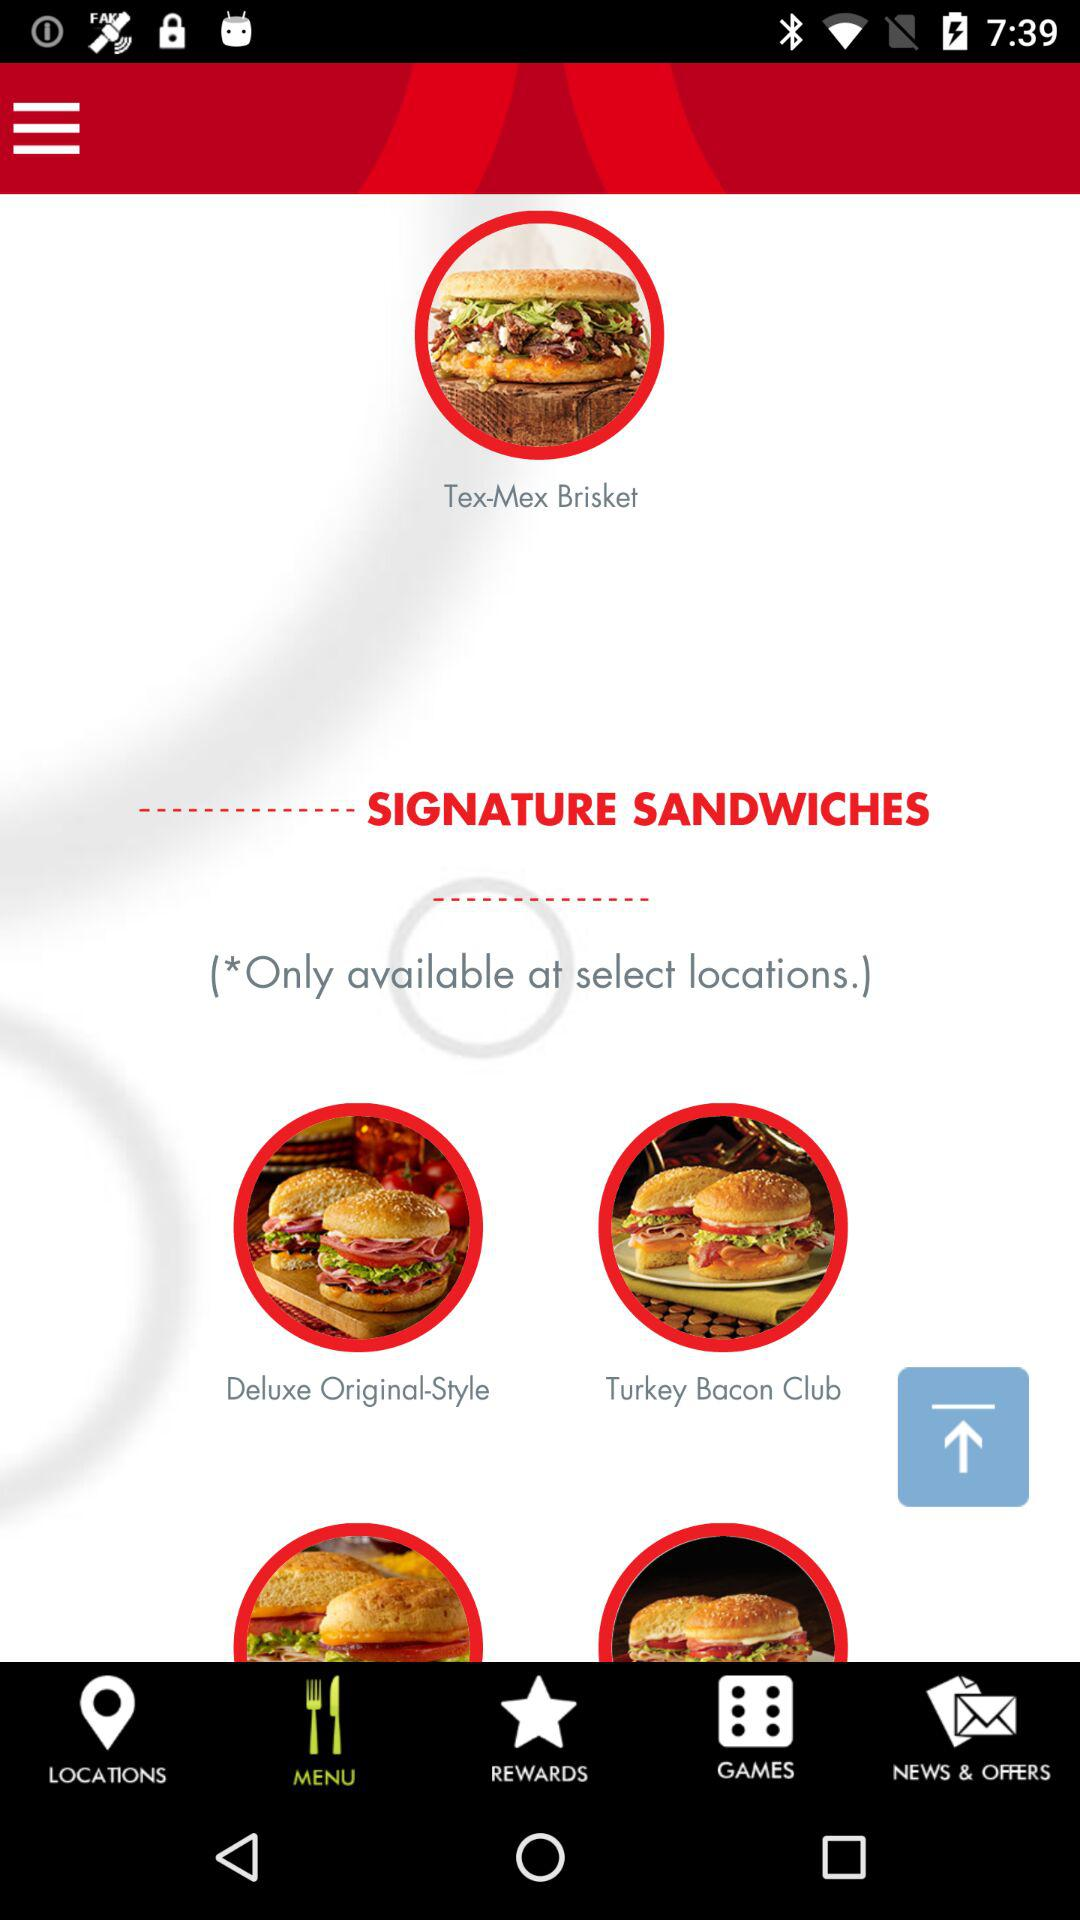What is the name of the application?
When the provided information is insufficient, respond with <no answer>. <no answer> 